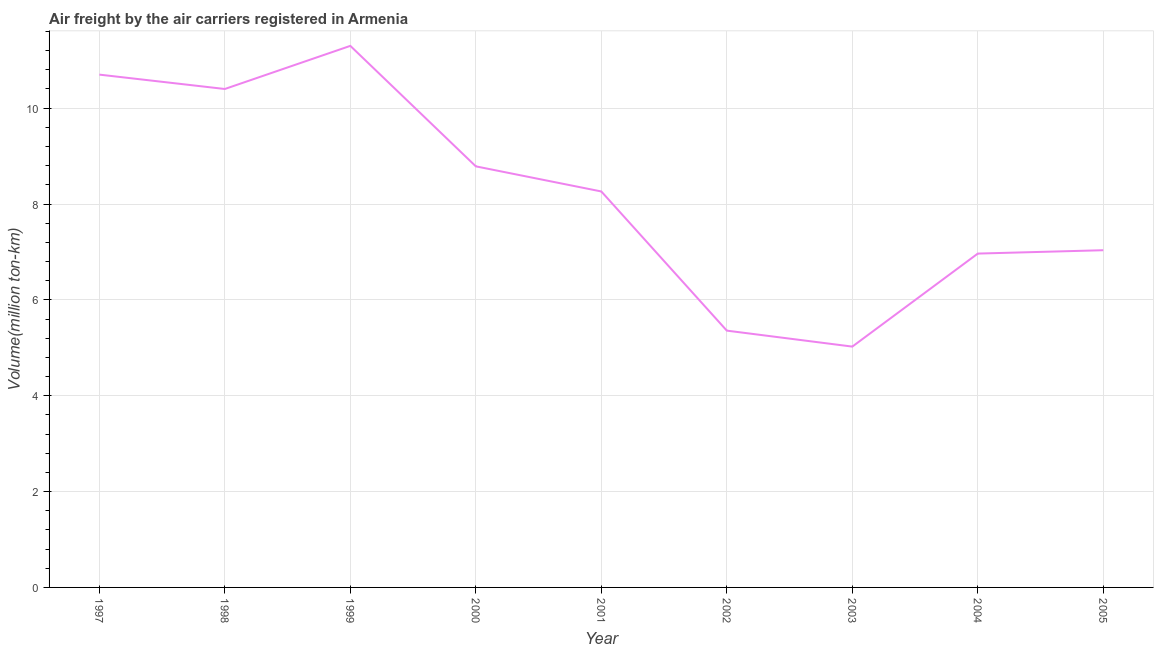What is the air freight in 1999?
Provide a short and direct response. 11.3. Across all years, what is the maximum air freight?
Keep it short and to the point. 11.3. Across all years, what is the minimum air freight?
Your response must be concise. 5.03. In which year was the air freight maximum?
Offer a very short reply. 1999. What is the sum of the air freight?
Provide a succinct answer. 73.83. What is the difference between the air freight in 2000 and 2002?
Ensure brevity in your answer.  3.43. What is the average air freight per year?
Offer a terse response. 8.2. What is the median air freight?
Offer a terse response. 8.26. Do a majority of the years between 2001 and 1999 (inclusive) have air freight greater than 8 million ton-km?
Make the answer very short. No. What is the ratio of the air freight in 1997 to that in 2001?
Provide a short and direct response. 1.3. Is the air freight in 1999 less than that in 2005?
Offer a very short reply. No. What is the difference between the highest and the second highest air freight?
Offer a terse response. 0.6. What is the difference between the highest and the lowest air freight?
Offer a terse response. 6.28. How many lines are there?
Ensure brevity in your answer.  1. How many years are there in the graph?
Your response must be concise. 9. Are the values on the major ticks of Y-axis written in scientific E-notation?
Provide a succinct answer. No. Does the graph contain any zero values?
Make the answer very short. No. Does the graph contain grids?
Your answer should be very brief. Yes. What is the title of the graph?
Give a very brief answer. Air freight by the air carriers registered in Armenia. What is the label or title of the X-axis?
Ensure brevity in your answer.  Year. What is the label or title of the Y-axis?
Provide a short and direct response. Volume(million ton-km). What is the Volume(million ton-km) of 1997?
Provide a short and direct response. 10.7. What is the Volume(million ton-km) in 1998?
Provide a succinct answer. 10.4. What is the Volume(million ton-km) of 1999?
Provide a succinct answer. 11.3. What is the Volume(million ton-km) in 2000?
Offer a very short reply. 8.79. What is the Volume(million ton-km) in 2001?
Ensure brevity in your answer.  8.26. What is the Volume(million ton-km) in 2002?
Provide a succinct answer. 5.36. What is the Volume(million ton-km) in 2003?
Give a very brief answer. 5.03. What is the Volume(million ton-km) in 2004?
Offer a very short reply. 6.97. What is the Volume(million ton-km) in 2005?
Your response must be concise. 7.04. What is the difference between the Volume(million ton-km) in 1997 and 1998?
Your answer should be very brief. 0.3. What is the difference between the Volume(million ton-km) in 1997 and 1999?
Provide a short and direct response. -0.6. What is the difference between the Volume(million ton-km) in 1997 and 2000?
Offer a terse response. 1.91. What is the difference between the Volume(million ton-km) in 1997 and 2001?
Your answer should be very brief. 2.44. What is the difference between the Volume(million ton-km) in 1997 and 2002?
Ensure brevity in your answer.  5.34. What is the difference between the Volume(million ton-km) in 1997 and 2003?
Your response must be concise. 5.67. What is the difference between the Volume(million ton-km) in 1997 and 2004?
Offer a very short reply. 3.73. What is the difference between the Volume(million ton-km) in 1997 and 2005?
Your response must be concise. 3.66. What is the difference between the Volume(million ton-km) in 1998 and 1999?
Provide a short and direct response. -0.9. What is the difference between the Volume(million ton-km) in 1998 and 2000?
Give a very brief answer. 1.61. What is the difference between the Volume(million ton-km) in 1998 and 2001?
Your response must be concise. 2.14. What is the difference between the Volume(million ton-km) in 1998 and 2002?
Keep it short and to the point. 5.04. What is the difference between the Volume(million ton-km) in 1998 and 2003?
Ensure brevity in your answer.  5.38. What is the difference between the Volume(million ton-km) in 1998 and 2004?
Offer a very short reply. 3.43. What is the difference between the Volume(million ton-km) in 1998 and 2005?
Keep it short and to the point. 3.36. What is the difference between the Volume(million ton-km) in 1999 and 2000?
Your answer should be compact. 2.51. What is the difference between the Volume(million ton-km) in 1999 and 2001?
Ensure brevity in your answer.  3.04. What is the difference between the Volume(million ton-km) in 1999 and 2002?
Ensure brevity in your answer.  5.94. What is the difference between the Volume(million ton-km) in 1999 and 2003?
Ensure brevity in your answer.  6.28. What is the difference between the Volume(million ton-km) in 1999 and 2004?
Provide a succinct answer. 4.33. What is the difference between the Volume(million ton-km) in 1999 and 2005?
Provide a succinct answer. 4.26. What is the difference between the Volume(million ton-km) in 2000 and 2001?
Keep it short and to the point. 0.52. What is the difference between the Volume(million ton-km) in 2000 and 2002?
Your response must be concise. 3.43. What is the difference between the Volume(million ton-km) in 2000 and 2003?
Give a very brief answer. 3.76. What is the difference between the Volume(million ton-km) in 2000 and 2004?
Give a very brief answer. 1.82. What is the difference between the Volume(million ton-km) in 2000 and 2005?
Your answer should be compact. 1.75. What is the difference between the Volume(million ton-km) in 2001 and 2002?
Give a very brief answer. 2.9. What is the difference between the Volume(million ton-km) in 2001 and 2003?
Give a very brief answer. 3.24. What is the difference between the Volume(million ton-km) in 2001 and 2004?
Your response must be concise. 1.3. What is the difference between the Volume(million ton-km) in 2001 and 2005?
Provide a short and direct response. 1.23. What is the difference between the Volume(million ton-km) in 2002 and 2003?
Ensure brevity in your answer.  0.33. What is the difference between the Volume(million ton-km) in 2002 and 2004?
Provide a succinct answer. -1.61. What is the difference between the Volume(million ton-km) in 2002 and 2005?
Offer a very short reply. -1.68. What is the difference between the Volume(million ton-km) in 2003 and 2004?
Ensure brevity in your answer.  -1.94. What is the difference between the Volume(million ton-km) in 2003 and 2005?
Ensure brevity in your answer.  -2.01. What is the difference between the Volume(million ton-km) in 2004 and 2005?
Offer a very short reply. -0.07. What is the ratio of the Volume(million ton-km) in 1997 to that in 1998?
Your answer should be very brief. 1.03. What is the ratio of the Volume(million ton-km) in 1997 to that in 1999?
Ensure brevity in your answer.  0.95. What is the ratio of the Volume(million ton-km) in 1997 to that in 2000?
Ensure brevity in your answer.  1.22. What is the ratio of the Volume(million ton-km) in 1997 to that in 2001?
Provide a short and direct response. 1.29. What is the ratio of the Volume(million ton-km) in 1997 to that in 2002?
Provide a succinct answer. 2. What is the ratio of the Volume(million ton-km) in 1997 to that in 2003?
Your response must be concise. 2.13. What is the ratio of the Volume(million ton-km) in 1997 to that in 2004?
Offer a very short reply. 1.54. What is the ratio of the Volume(million ton-km) in 1997 to that in 2005?
Your response must be concise. 1.52. What is the ratio of the Volume(million ton-km) in 1998 to that in 1999?
Ensure brevity in your answer.  0.92. What is the ratio of the Volume(million ton-km) in 1998 to that in 2000?
Give a very brief answer. 1.18. What is the ratio of the Volume(million ton-km) in 1998 to that in 2001?
Provide a short and direct response. 1.26. What is the ratio of the Volume(million ton-km) in 1998 to that in 2002?
Offer a very short reply. 1.94. What is the ratio of the Volume(million ton-km) in 1998 to that in 2003?
Make the answer very short. 2.07. What is the ratio of the Volume(million ton-km) in 1998 to that in 2004?
Provide a short and direct response. 1.49. What is the ratio of the Volume(million ton-km) in 1998 to that in 2005?
Keep it short and to the point. 1.48. What is the ratio of the Volume(million ton-km) in 1999 to that in 2000?
Provide a succinct answer. 1.29. What is the ratio of the Volume(million ton-km) in 1999 to that in 2001?
Your answer should be compact. 1.37. What is the ratio of the Volume(million ton-km) in 1999 to that in 2002?
Offer a terse response. 2.11. What is the ratio of the Volume(million ton-km) in 1999 to that in 2003?
Provide a short and direct response. 2.25. What is the ratio of the Volume(million ton-km) in 1999 to that in 2004?
Offer a terse response. 1.62. What is the ratio of the Volume(million ton-km) in 1999 to that in 2005?
Your answer should be very brief. 1.61. What is the ratio of the Volume(million ton-km) in 2000 to that in 2001?
Provide a succinct answer. 1.06. What is the ratio of the Volume(million ton-km) in 2000 to that in 2002?
Make the answer very short. 1.64. What is the ratio of the Volume(million ton-km) in 2000 to that in 2003?
Offer a very short reply. 1.75. What is the ratio of the Volume(million ton-km) in 2000 to that in 2004?
Offer a very short reply. 1.26. What is the ratio of the Volume(million ton-km) in 2000 to that in 2005?
Provide a short and direct response. 1.25. What is the ratio of the Volume(million ton-km) in 2001 to that in 2002?
Keep it short and to the point. 1.54. What is the ratio of the Volume(million ton-km) in 2001 to that in 2003?
Your response must be concise. 1.64. What is the ratio of the Volume(million ton-km) in 2001 to that in 2004?
Your response must be concise. 1.19. What is the ratio of the Volume(million ton-km) in 2001 to that in 2005?
Give a very brief answer. 1.17. What is the ratio of the Volume(million ton-km) in 2002 to that in 2003?
Make the answer very short. 1.07. What is the ratio of the Volume(million ton-km) in 2002 to that in 2004?
Your answer should be compact. 0.77. What is the ratio of the Volume(million ton-km) in 2002 to that in 2005?
Your answer should be compact. 0.76. What is the ratio of the Volume(million ton-km) in 2003 to that in 2004?
Your answer should be compact. 0.72. What is the ratio of the Volume(million ton-km) in 2003 to that in 2005?
Offer a very short reply. 0.71. What is the ratio of the Volume(million ton-km) in 2004 to that in 2005?
Offer a terse response. 0.99. 